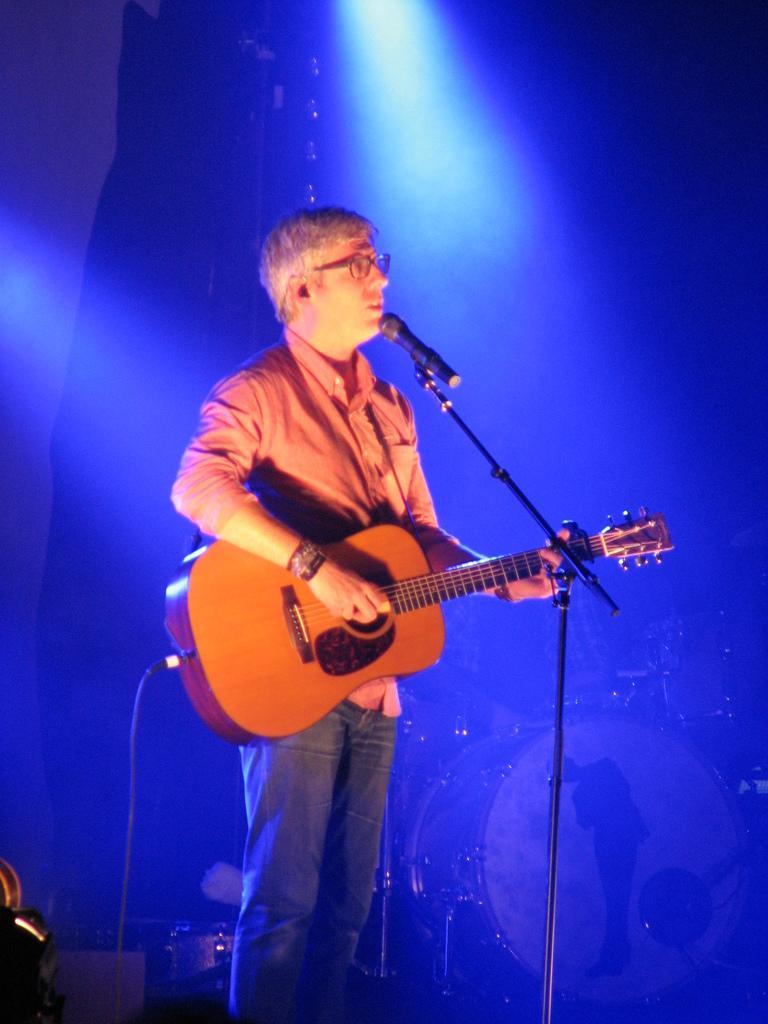What is the man in the image doing? The man is playing the guitar and appears to be singing. What object is in front of the man? There is a microphone stand in front of the man. What other musical instrument can be seen in the image? There are drums visible in the background of the image. Can you tell me how many yams are on the stage in the image? There are no yams present in the image; it features a man playing the guitar, a microphone stand, and drums in the background. Is there any chalk visible on the stage in the image? There is no chalk present in the image. 